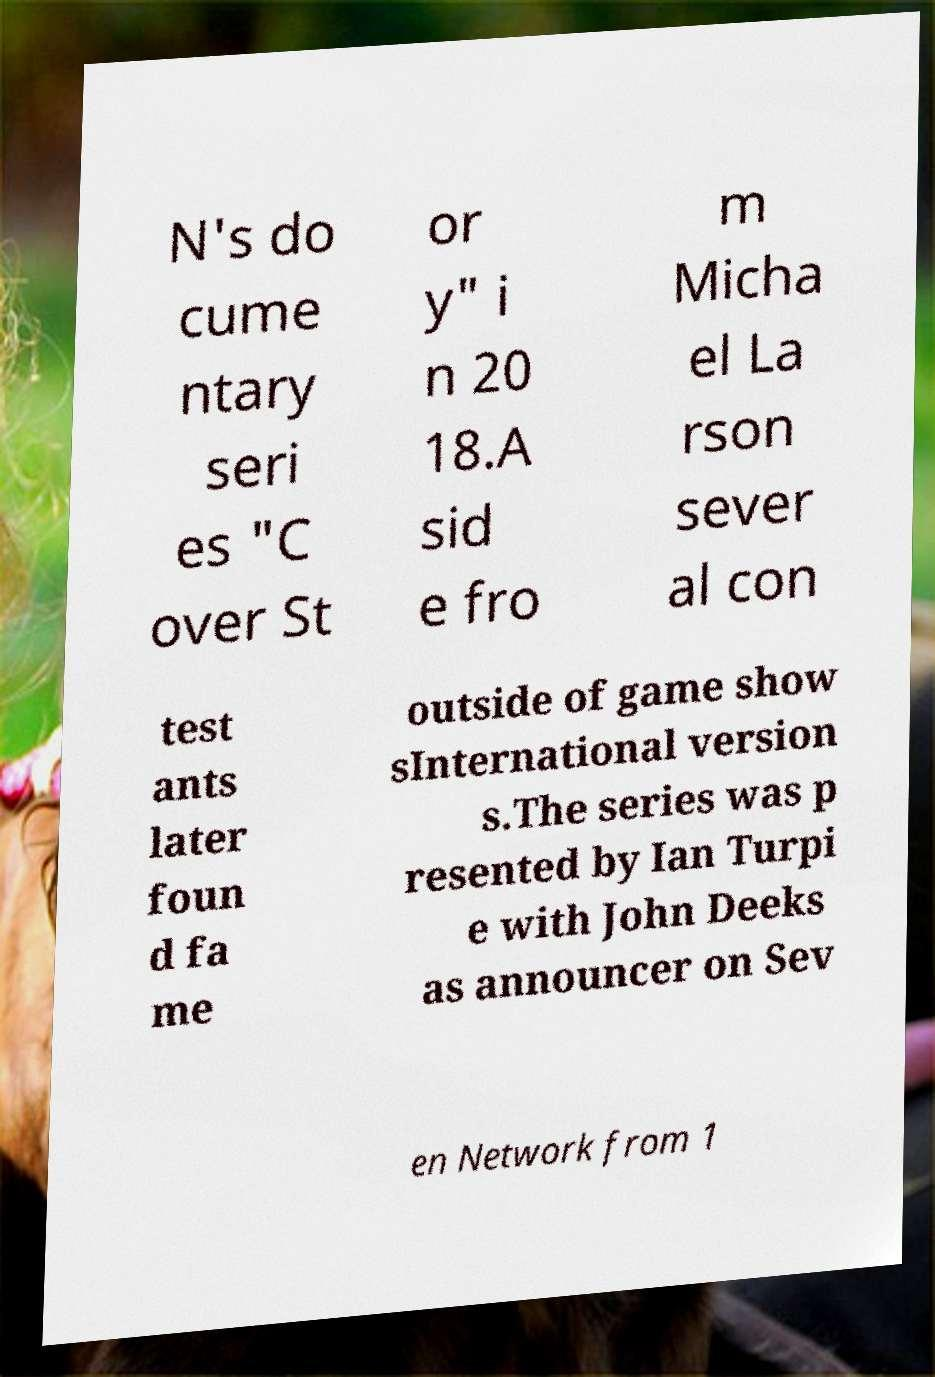Please read and relay the text visible in this image. What does it say? N's do cume ntary seri es "C over St or y" i n 20 18.A sid e fro m Micha el La rson sever al con test ants later foun d fa me outside of game show sInternational version s.The series was p resented by Ian Turpi e with John Deeks as announcer on Sev en Network from 1 